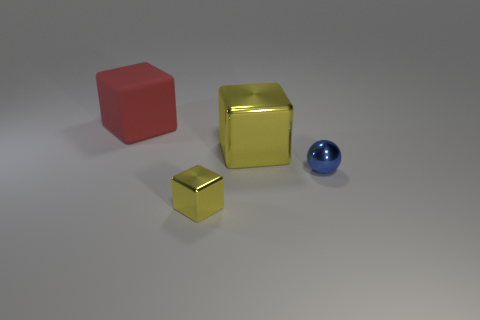Add 4 tiny metallic cubes. How many objects exist? 8 Subtract all spheres. How many objects are left? 3 Subtract all large green metallic things. Subtract all big red rubber things. How many objects are left? 3 Add 3 tiny spheres. How many tiny spheres are left? 4 Add 2 big red things. How many big red things exist? 3 Subtract 0 brown cylinders. How many objects are left? 4 